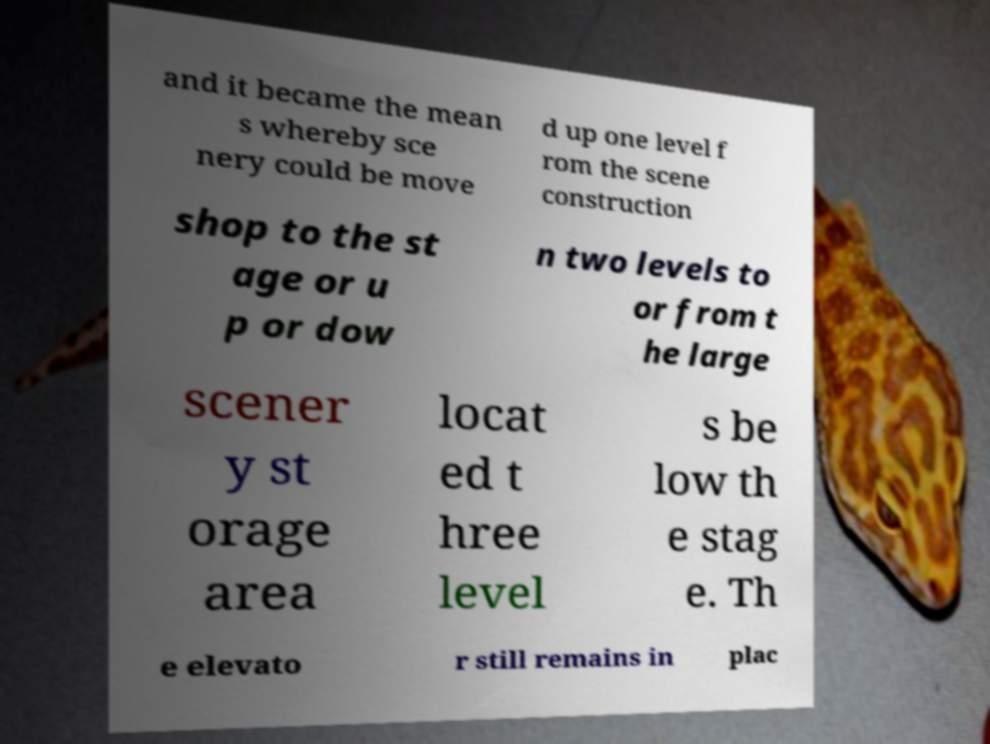There's text embedded in this image that I need extracted. Can you transcribe it verbatim? and it became the mean s whereby sce nery could be move d up one level f rom the scene construction shop to the st age or u p or dow n two levels to or from t he large scener y st orage area locat ed t hree level s be low th e stag e. Th e elevato r still remains in plac 